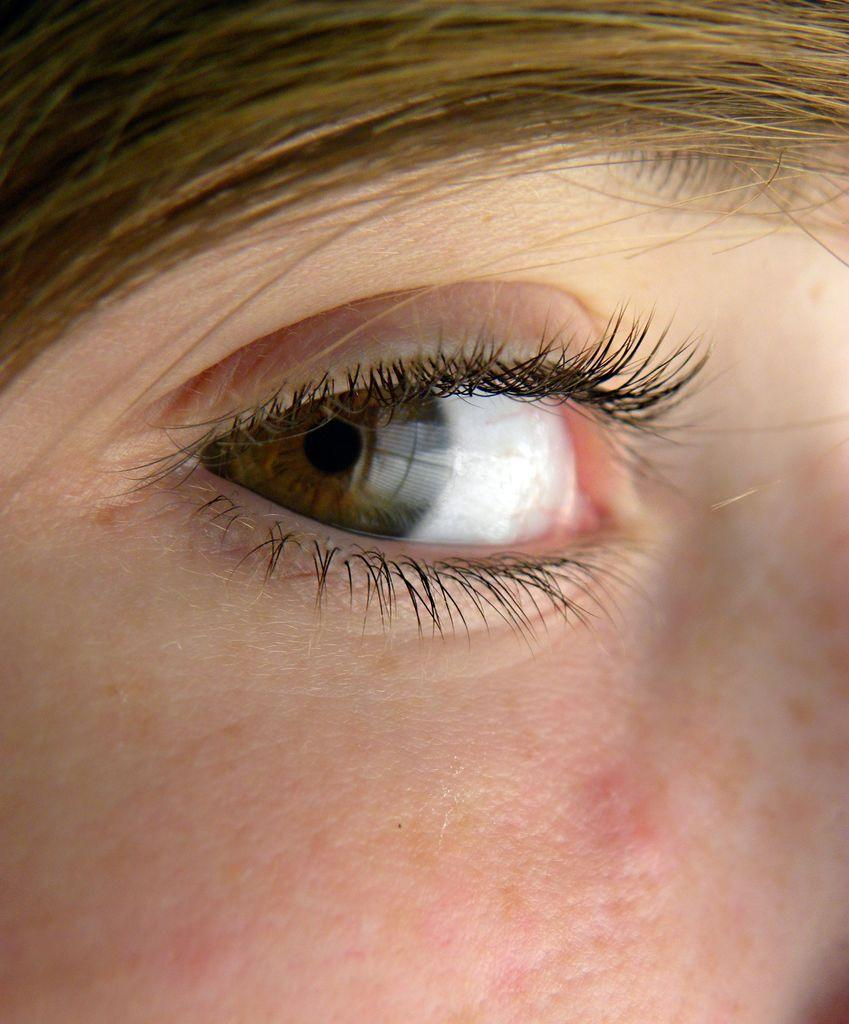What is the main subject of the image? There is a human face in the image. What facial feature can be seen on the face? The face has an eye and an eyebrow. How is the eye and eyebrow of the face depicted? The eye and eyebrow are covered with hair. What is the voice of the face in the image? The image does not depict a voice, as it is a visual representation of a face. Can you tell me how many arches are present in the image? There are no arches depicted in the image; it features a human face with an eye and eyebrow covered with hair. 